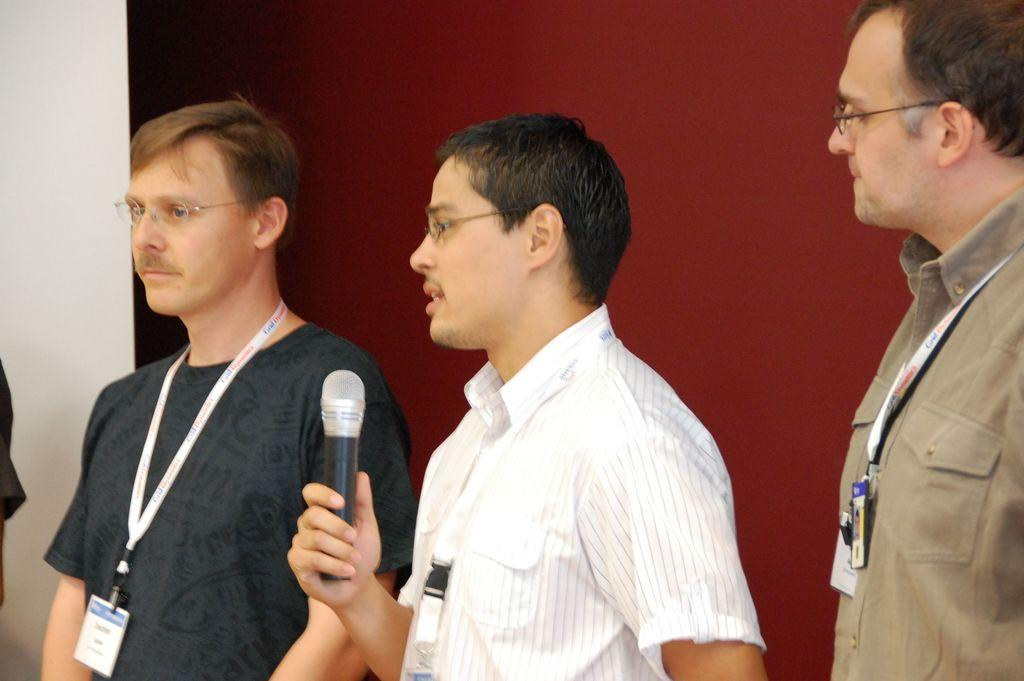How many people are present in the image? There are three people standing in the image. What are the people wearing that can be seen in the image? The people are wearing white color tags. What is the person in the middle holding? The person in the middle is holding a microphone. What is the person in the middle doing? The person in the middle is speaking. What is the color of the background in the image? The background color appears to be maroon. Can you tell me how many bees are flying around the person in the middle? There are no bees present in the image; it only features three people standing and the person in the middle holding a microphone. 